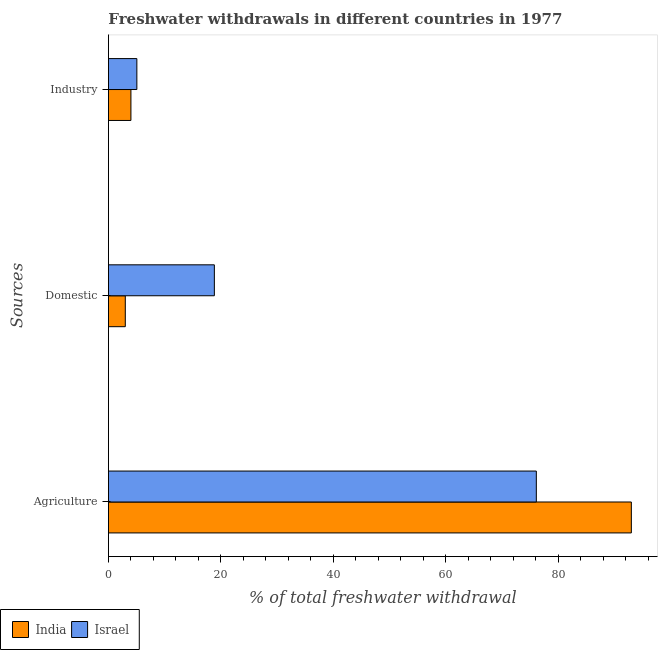How many bars are there on the 3rd tick from the top?
Your answer should be very brief. 2. How many bars are there on the 2nd tick from the bottom?
Your answer should be compact. 2. What is the label of the 2nd group of bars from the top?
Your answer should be compact. Domestic. What is the percentage of freshwater withdrawal for industry in India?
Provide a succinct answer. 4. Across all countries, what is the maximum percentage of freshwater withdrawal for domestic purposes?
Offer a terse response. 18.84. Across all countries, what is the minimum percentage of freshwater withdrawal for agriculture?
Give a very brief answer. 76.1. In which country was the percentage of freshwater withdrawal for agriculture maximum?
Offer a very short reply. India. In which country was the percentage of freshwater withdrawal for agriculture minimum?
Provide a succinct answer. Israel. What is the total percentage of freshwater withdrawal for domestic purposes in the graph?
Give a very brief answer. 21.84. What is the difference between the percentage of freshwater withdrawal for agriculture in Israel and that in India?
Give a very brief answer. -16.9. What is the difference between the percentage of freshwater withdrawal for agriculture in India and the percentage of freshwater withdrawal for industry in Israel?
Make the answer very short. 87.94. What is the average percentage of freshwater withdrawal for industry per country?
Your answer should be compact. 4.53. What is the difference between the percentage of freshwater withdrawal for industry and percentage of freshwater withdrawal for domestic purposes in India?
Ensure brevity in your answer.  1. In how many countries, is the percentage of freshwater withdrawal for domestic purposes greater than 4 %?
Give a very brief answer. 1. What is the ratio of the percentage of freshwater withdrawal for industry in India to that in Israel?
Give a very brief answer. 0.79. Is the percentage of freshwater withdrawal for domestic purposes in Israel less than that in India?
Keep it short and to the point. No. Is the difference between the percentage of freshwater withdrawal for domestic purposes in Israel and India greater than the difference between the percentage of freshwater withdrawal for industry in Israel and India?
Offer a terse response. Yes. What is the difference between the highest and the second highest percentage of freshwater withdrawal for industry?
Give a very brief answer. 1.05. What is the difference between the highest and the lowest percentage of freshwater withdrawal for industry?
Provide a succinct answer. 1.05. Is the sum of the percentage of freshwater withdrawal for industry in India and Israel greater than the maximum percentage of freshwater withdrawal for agriculture across all countries?
Offer a very short reply. No. What does the 2nd bar from the bottom in Domestic represents?
Ensure brevity in your answer.  Israel. How many bars are there?
Offer a very short reply. 6. Are all the bars in the graph horizontal?
Make the answer very short. Yes. What is the difference between two consecutive major ticks on the X-axis?
Your response must be concise. 20. Does the graph contain any zero values?
Offer a terse response. No. Does the graph contain grids?
Give a very brief answer. No. Where does the legend appear in the graph?
Your answer should be compact. Bottom left. How many legend labels are there?
Offer a very short reply. 2. How are the legend labels stacked?
Offer a very short reply. Horizontal. What is the title of the graph?
Your response must be concise. Freshwater withdrawals in different countries in 1977. Does "Europe(all income levels)" appear as one of the legend labels in the graph?
Offer a terse response. No. What is the label or title of the X-axis?
Your answer should be very brief. % of total freshwater withdrawal. What is the label or title of the Y-axis?
Your answer should be compact. Sources. What is the % of total freshwater withdrawal in India in Agriculture?
Provide a short and direct response. 93. What is the % of total freshwater withdrawal in Israel in Agriculture?
Ensure brevity in your answer.  76.1. What is the % of total freshwater withdrawal of Israel in Domestic?
Keep it short and to the point. 18.84. What is the % of total freshwater withdrawal in Israel in Industry?
Provide a succinct answer. 5.05. Across all Sources, what is the maximum % of total freshwater withdrawal of India?
Provide a succinct answer. 93. Across all Sources, what is the maximum % of total freshwater withdrawal of Israel?
Keep it short and to the point. 76.1. Across all Sources, what is the minimum % of total freshwater withdrawal in India?
Make the answer very short. 3. Across all Sources, what is the minimum % of total freshwater withdrawal in Israel?
Offer a very short reply. 5.05. What is the total % of total freshwater withdrawal in India in the graph?
Give a very brief answer. 100. What is the total % of total freshwater withdrawal in Israel in the graph?
Offer a very short reply. 100. What is the difference between the % of total freshwater withdrawal of India in Agriculture and that in Domestic?
Offer a very short reply. 90. What is the difference between the % of total freshwater withdrawal of Israel in Agriculture and that in Domestic?
Your answer should be very brief. 57.26. What is the difference between the % of total freshwater withdrawal in India in Agriculture and that in Industry?
Keep it short and to the point. 89. What is the difference between the % of total freshwater withdrawal in Israel in Agriculture and that in Industry?
Keep it short and to the point. 71.05. What is the difference between the % of total freshwater withdrawal in India in Domestic and that in Industry?
Your response must be concise. -1. What is the difference between the % of total freshwater withdrawal in Israel in Domestic and that in Industry?
Give a very brief answer. 13.79. What is the difference between the % of total freshwater withdrawal in India in Agriculture and the % of total freshwater withdrawal in Israel in Domestic?
Provide a succinct answer. 74.16. What is the difference between the % of total freshwater withdrawal in India in Agriculture and the % of total freshwater withdrawal in Israel in Industry?
Provide a short and direct response. 87.94. What is the difference between the % of total freshwater withdrawal in India in Domestic and the % of total freshwater withdrawal in Israel in Industry?
Keep it short and to the point. -2.06. What is the average % of total freshwater withdrawal of India per Sources?
Make the answer very short. 33.33. What is the average % of total freshwater withdrawal of Israel per Sources?
Offer a very short reply. 33.33. What is the difference between the % of total freshwater withdrawal in India and % of total freshwater withdrawal in Israel in Agriculture?
Provide a short and direct response. 16.9. What is the difference between the % of total freshwater withdrawal of India and % of total freshwater withdrawal of Israel in Domestic?
Give a very brief answer. -15.84. What is the difference between the % of total freshwater withdrawal in India and % of total freshwater withdrawal in Israel in Industry?
Offer a terse response. -1.05. What is the ratio of the % of total freshwater withdrawal of India in Agriculture to that in Domestic?
Offer a terse response. 31. What is the ratio of the % of total freshwater withdrawal in Israel in Agriculture to that in Domestic?
Ensure brevity in your answer.  4.04. What is the ratio of the % of total freshwater withdrawal in India in Agriculture to that in Industry?
Provide a short and direct response. 23.25. What is the ratio of the % of total freshwater withdrawal of Israel in Agriculture to that in Industry?
Keep it short and to the point. 15.05. What is the ratio of the % of total freshwater withdrawal in Israel in Domestic to that in Industry?
Make the answer very short. 3.73. What is the difference between the highest and the second highest % of total freshwater withdrawal in India?
Your answer should be compact. 89. What is the difference between the highest and the second highest % of total freshwater withdrawal in Israel?
Your answer should be compact. 57.26. What is the difference between the highest and the lowest % of total freshwater withdrawal of India?
Your response must be concise. 90. What is the difference between the highest and the lowest % of total freshwater withdrawal in Israel?
Your answer should be very brief. 71.05. 